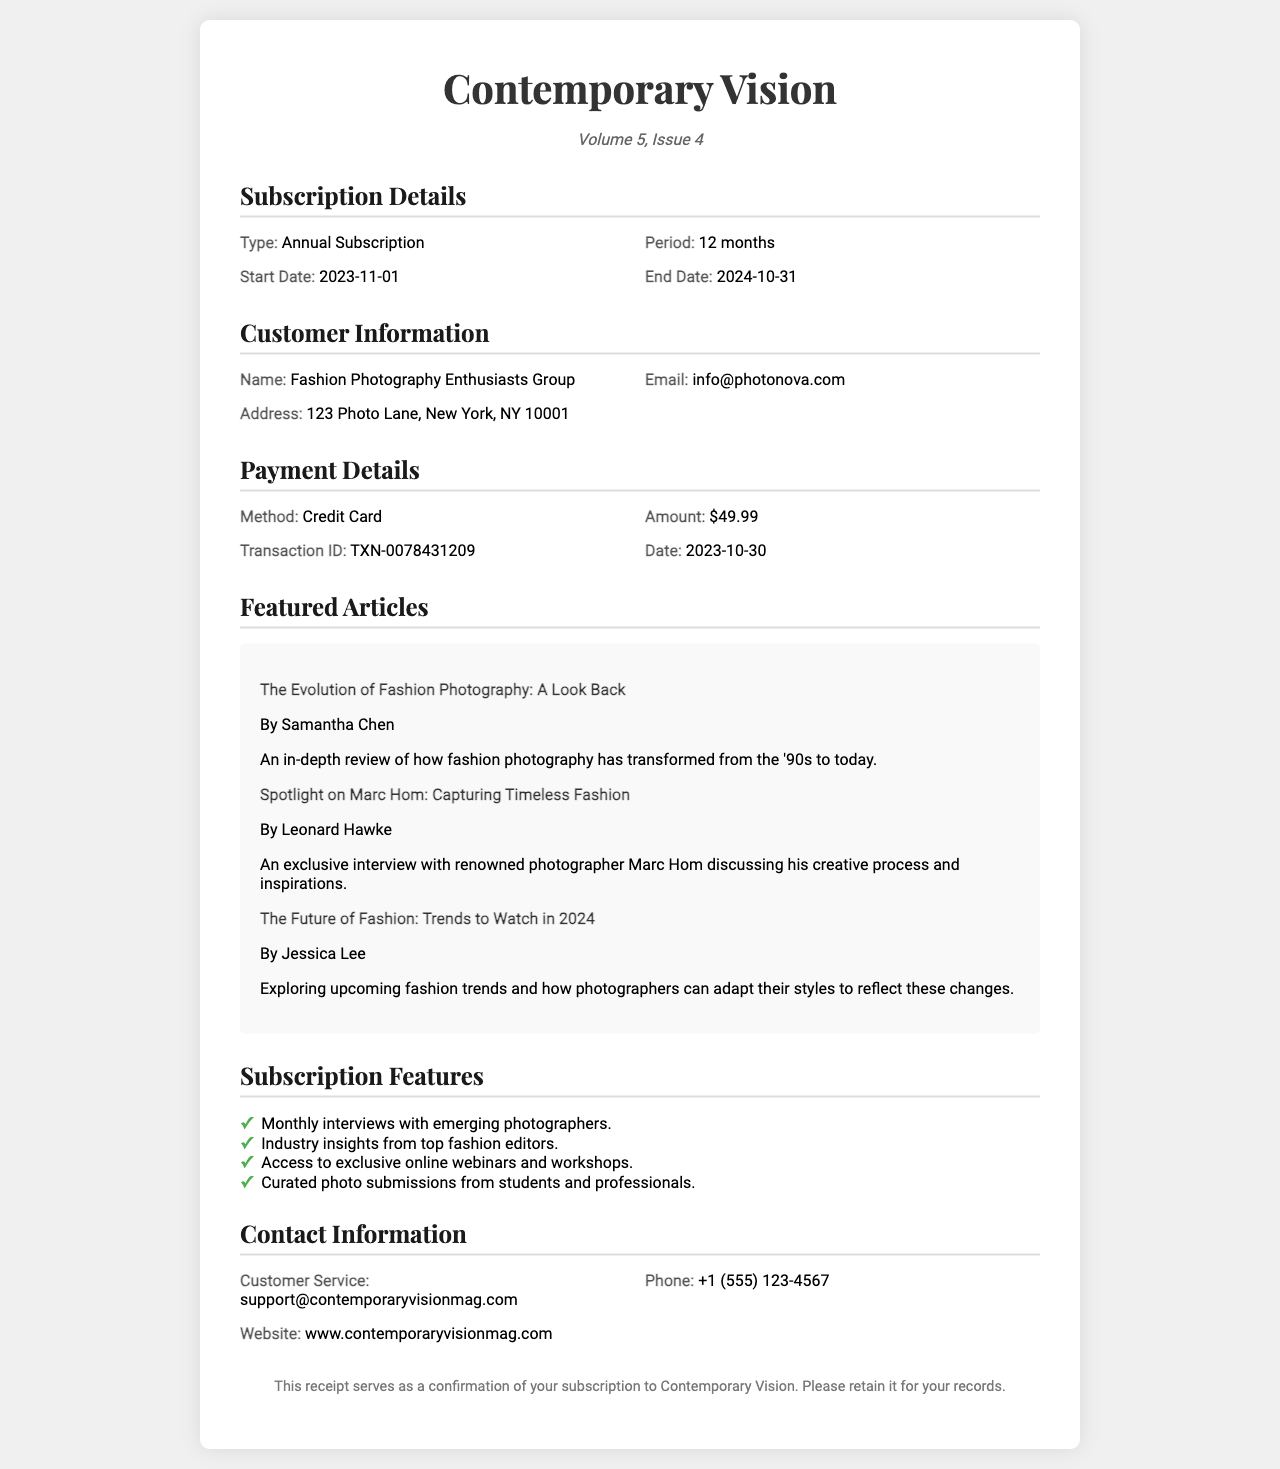What is the subscription type? The document states that the subscription type is indicated under "Subscription Details."
Answer: Annual Subscription What is the subscription period? The period of the subscription is mentioned alongside the type in the document.
Answer: 12 months What is the start date of the subscription? The start date is specified in the Subscription Details section.
Answer: 2023-11-01 What is the end date of the subscription? The end date is also listed in the Subscription Details section.
Answer: 2024-10-31 Who is the author of the article "Spotlight on Marc Hom: Capturing Timeless Fashion"? The author of this featured article is provided underneath the title in the document.
Answer: Leonard Hawke What is the transaction ID mentioned in the payment details? The transaction ID can be found in the Payment Details section of the receipt.
Answer: TXN-0078431209 What method of payment was used? The payment method is clearly stated in the Payment Details section.
Answer: Credit Card What is the amount charged for the subscription? The amount is outlined in the Payment Details section of the receipt.
Answer: $49.99 What type of articles does the subscription provide? The types of content provided under the subscription are listed in the Subscription Features section.
Answer: Monthly interviews with emerging photographers 